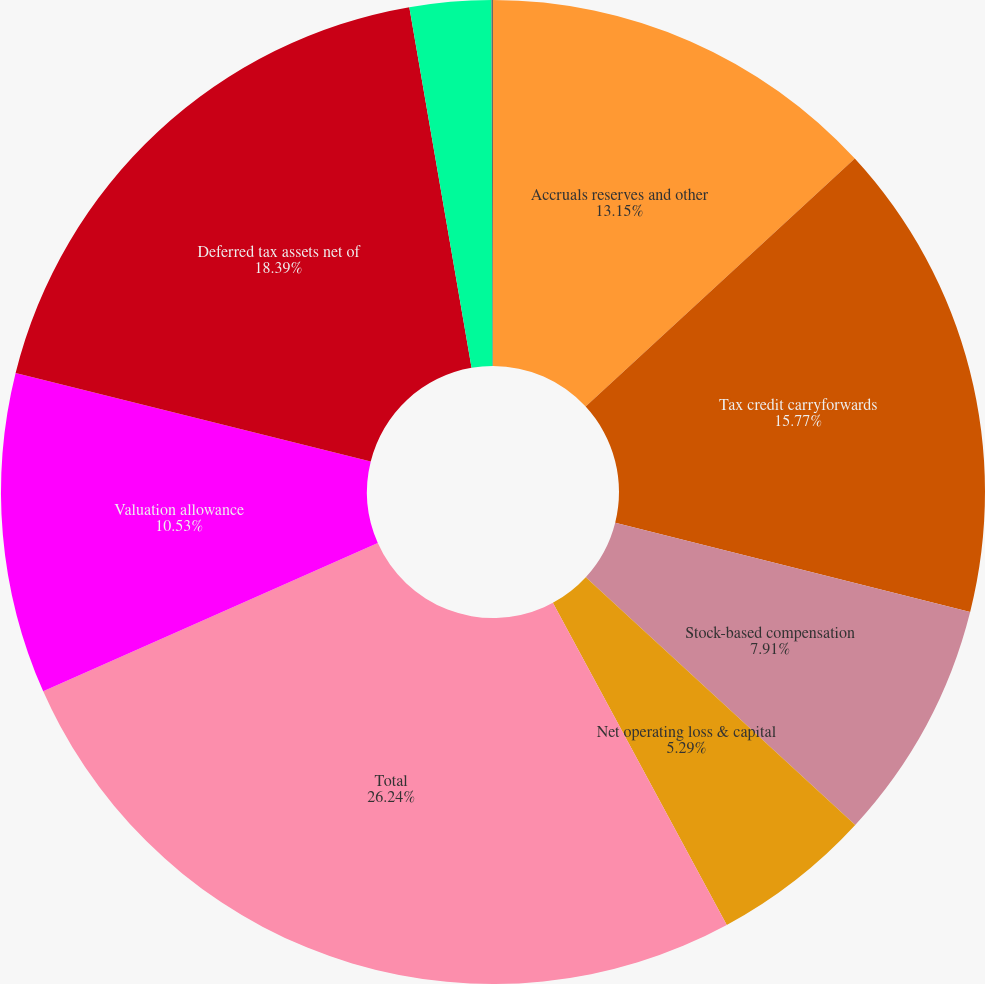Convert chart to OTSL. <chart><loc_0><loc_0><loc_500><loc_500><pie_chart><fcel>Accruals reserves and other<fcel>Tax credit carryforwards<fcel>Stock-based compensation<fcel>Net operating loss & capital<fcel>Total<fcel>Valuation allowance<fcel>Deferred tax assets net of<fcel>Amortization and depreciation<fcel>Prepaids and other liabilities<nl><fcel>13.15%<fcel>15.77%<fcel>7.91%<fcel>5.29%<fcel>26.24%<fcel>10.53%<fcel>18.39%<fcel>2.67%<fcel>0.05%<nl></chart> 